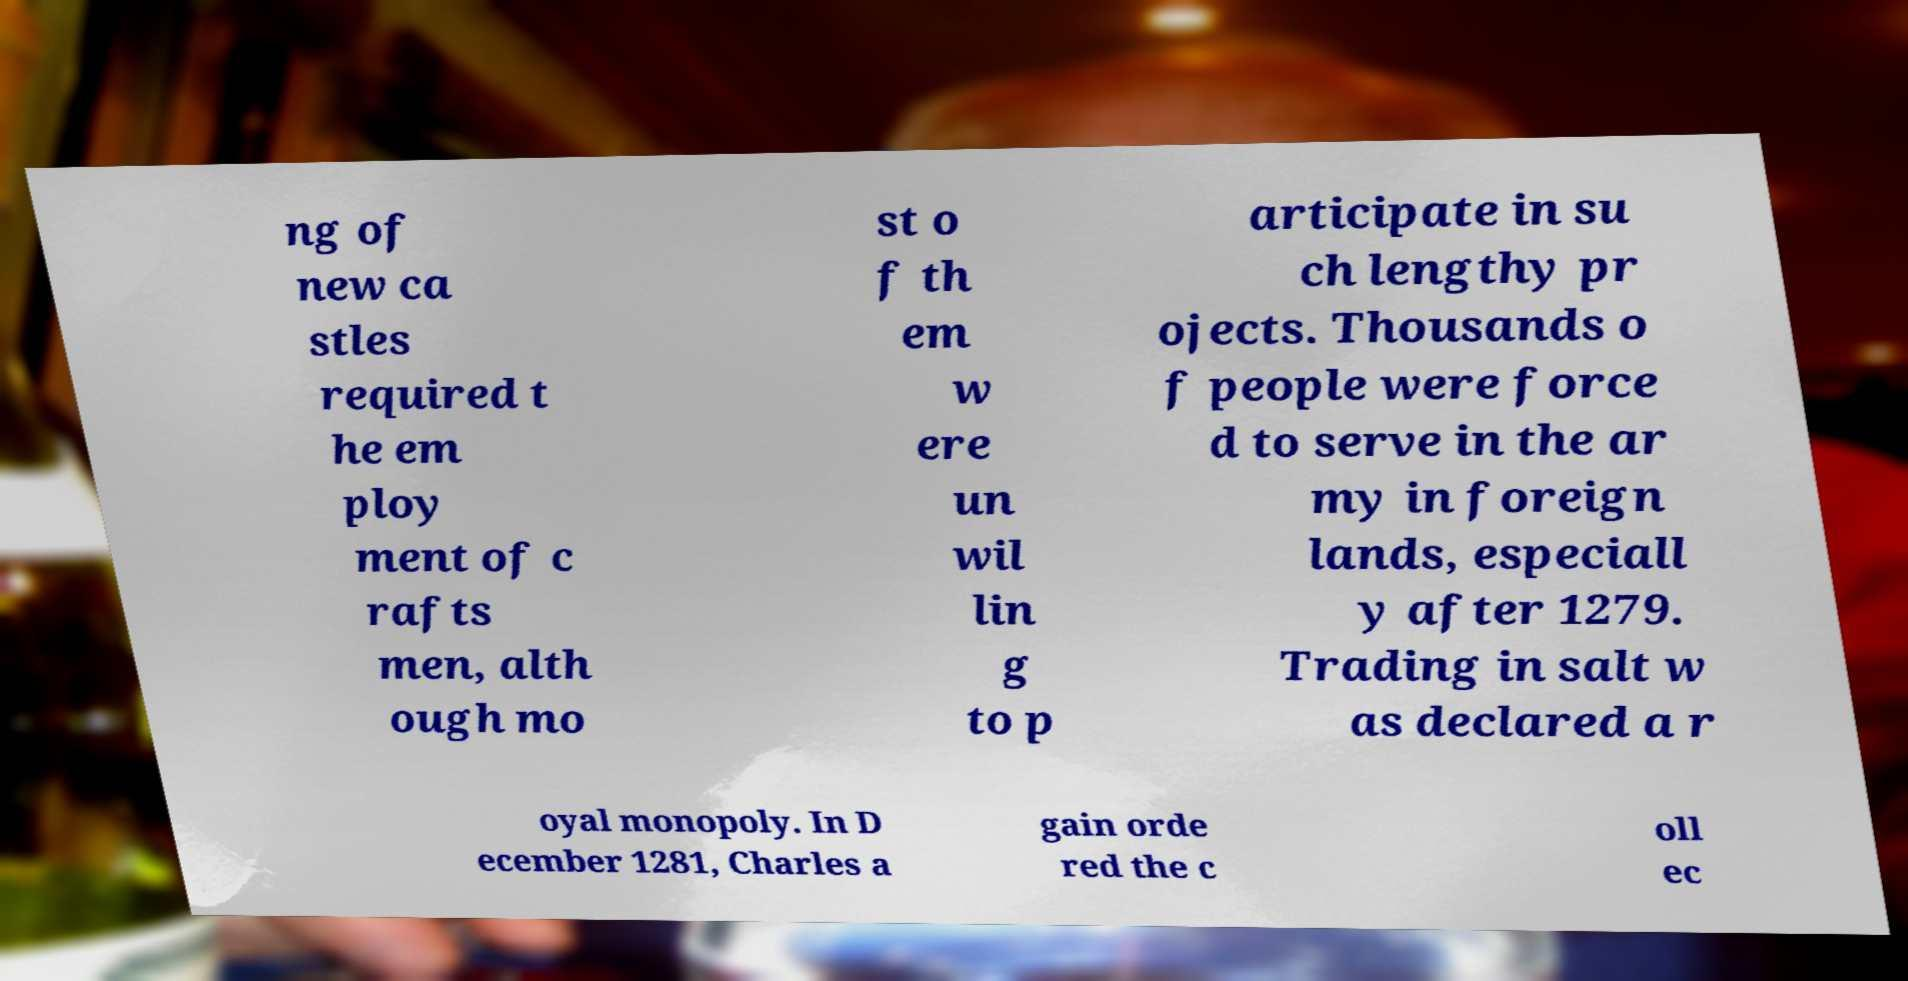What messages or text are displayed in this image? I need them in a readable, typed format. ng of new ca stles required t he em ploy ment of c rafts men, alth ough mo st o f th em w ere un wil lin g to p articipate in su ch lengthy pr ojects. Thousands o f people were force d to serve in the ar my in foreign lands, especiall y after 1279. Trading in salt w as declared a r oyal monopoly. In D ecember 1281, Charles a gain orde red the c oll ec 